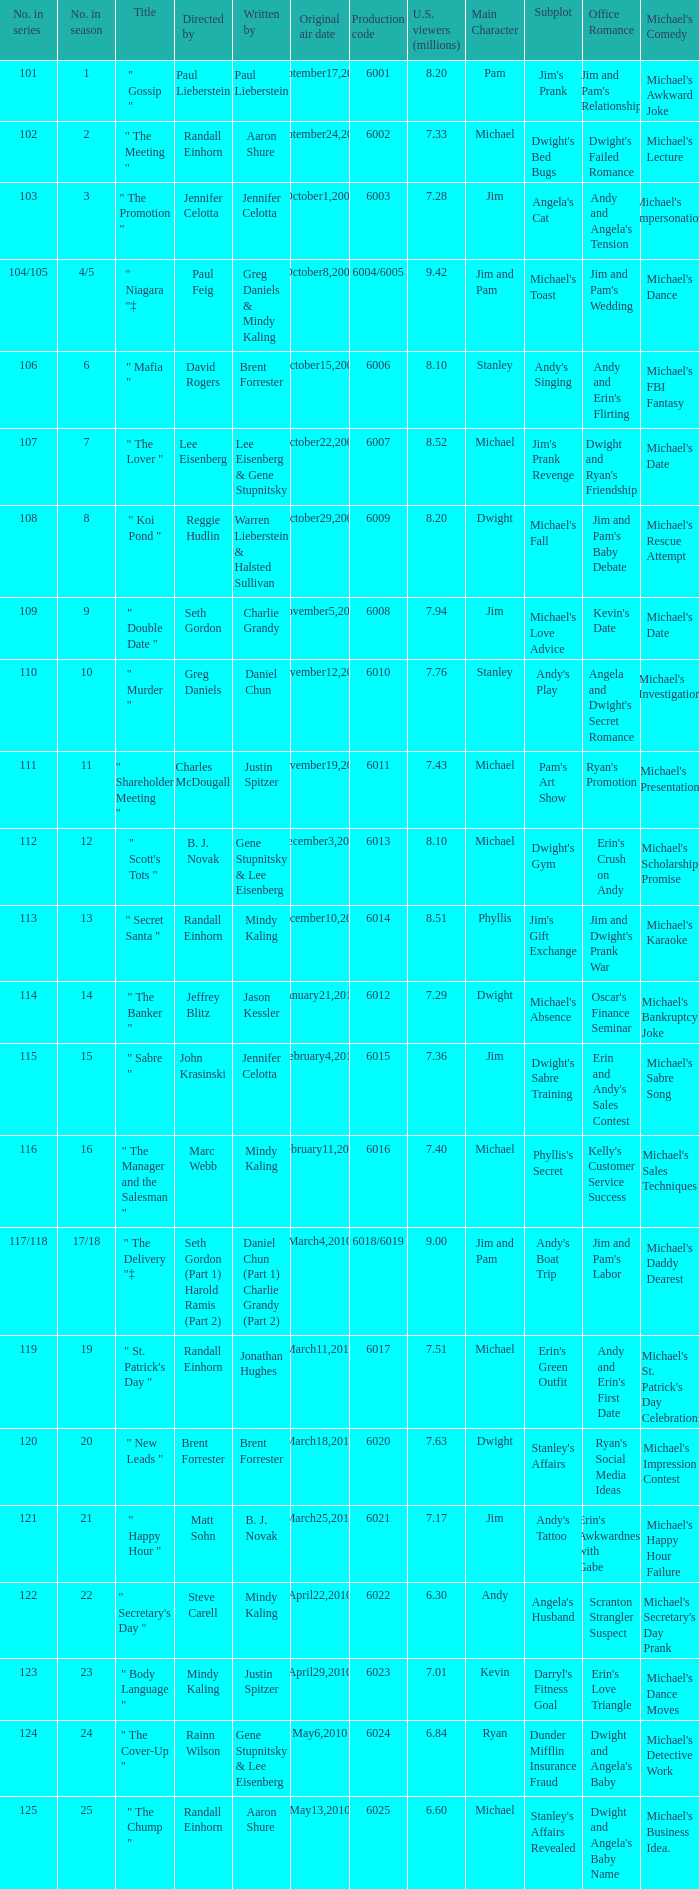Name the production code for number in season being 21 6021.0. 